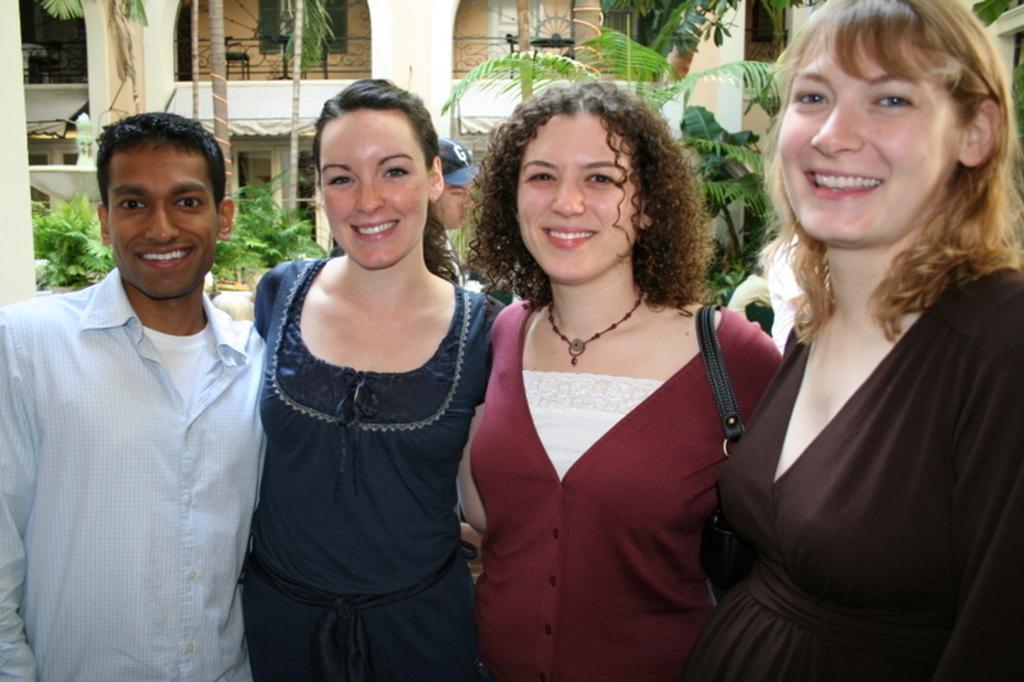How would you summarize this image in a sentence or two? In this picture I can see a man and 3 women standing in front and I see that they are smiling. Behind them I can see a person who is wearing cap. In the background I can see a building and number of trees. 